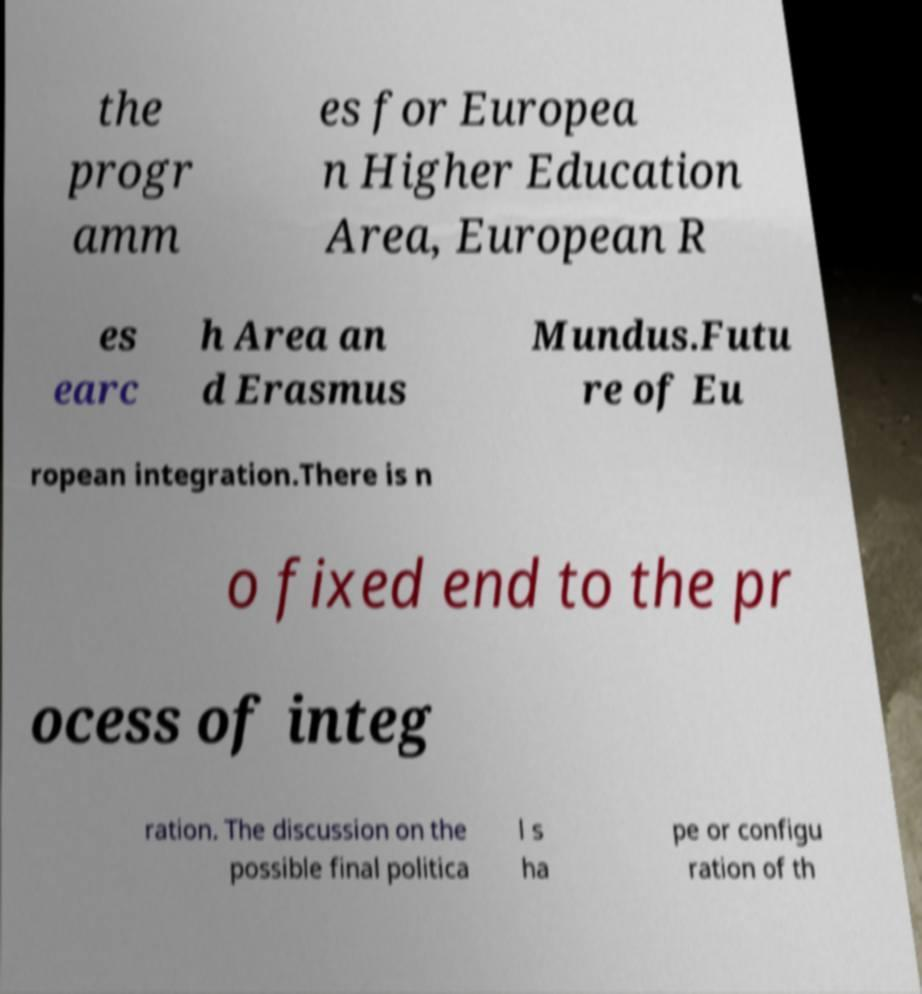Please identify and transcribe the text found in this image. the progr amm es for Europea n Higher Education Area, European R es earc h Area an d Erasmus Mundus.Futu re of Eu ropean integration.There is n o fixed end to the pr ocess of integ ration. The discussion on the possible final politica l s ha pe or configu ration of th 